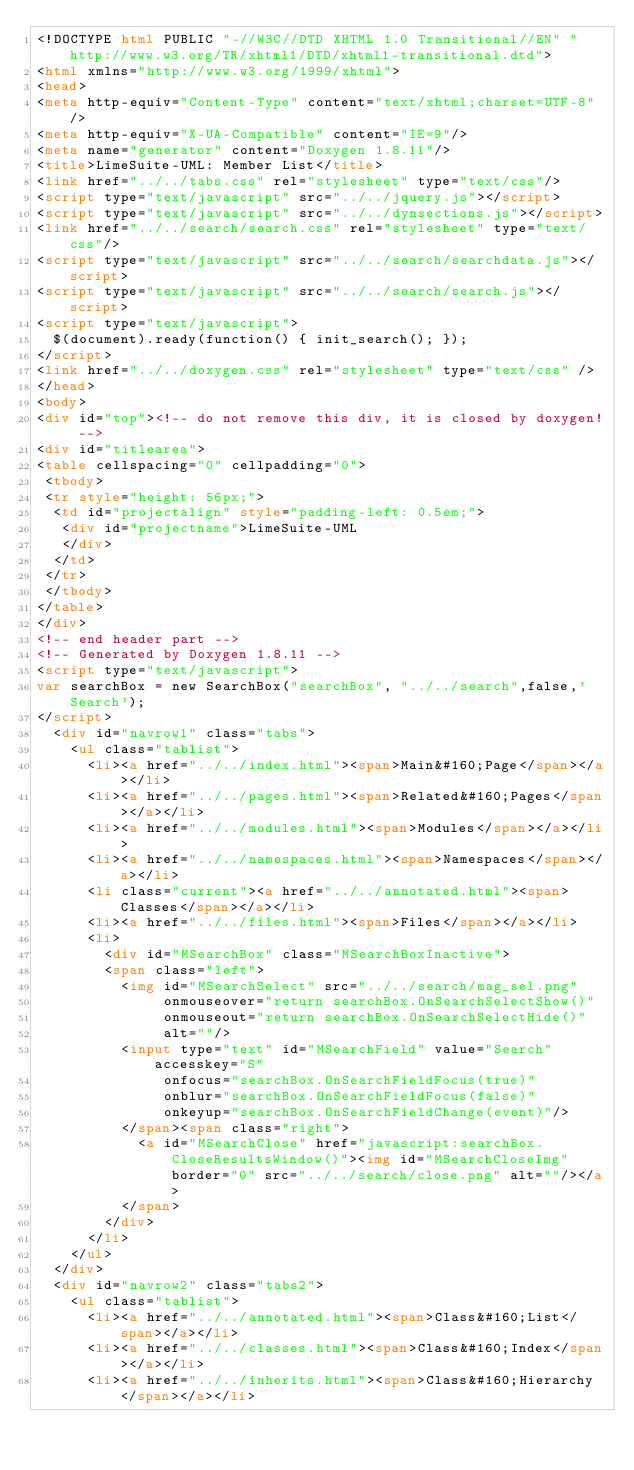Convert code to text. <code><loc_0><loc_0><loc_500><loc_500><_HTML_><!DOCTYPE html PUBLIC "-//W3C//DTD XHTML 1.0 Transitional//EN" "http://www.w3.org/TR/xhtml1/DTD/xhtml1-transitional.dtd">
<html xmlns="http://www.w3.org/1999/xhtml">
<head>
<meta http-equiv="Content-Type" content="text/xhtml;charset=UTF-8"/>
<meta http-equiv="X-UA-Compatible" content="IE=9"/>
<meta name="generator" content="Doxygen 1.8.11"/>
<title>LimeSuite-UML: Member List</title>
<link href="../../tabs.css" rel="stylesheet" type="text/css"/>
<script type="text/javascript" src="../../jquery.js"></script>
<script type="text/javascript" src="../../dynsections.js"></script>
<link href="../../search/search.css" rel="stylesheet" type="text/css"/>
<script type="text/javascript" src="../../search/searchdata.js"></script>
<script type="text/javascript" src="../../search/search.js"></script>
<script type="text/javascript">
  $(document).ready(function() { init_search(); });
</script>
<link href="../../doxygen.css" rel="stylesheet" type="text/css" />
</head>
<body>
<div id="top"><!-- do not remove this div, it is closed by doxygen! -->
<div id="titlearea">
<table cellspacing="0" cellpadding="0">
 <tbody>
 <tr style="height: 56px;">
  <td id="projectalign" style="padding-left: 0.5em;">
   <div id="projectname">LimeSuite-UML
   </div>
  </td>
 </tr>
 </tbody>
</table>
</div>
<!-- end header part -->
<!-- Generated by Doxygen 1.8.11 -->
<script type="text/javascript">
var searchBox = new SearchBox("searchBox", "../../search",false,'Search');
</script>
  <div id="navrow1" class="tabs">
    <ul class="tablist">
      <li><a href="../../index.html"><span>Main&#160;Page</span></a></li>
      <li><a href="../../pages.html"><span>Related&#160;Pages</span></a></li>
      <li><a href="../../modules.html"><span>Modules</span></a></li>
      <li><a href="../../namespaces.html"><span>Namespaces</span></a></li>
      <li class="current"><a href="../../annotated.html"><span>Classes</span></a></li>
      <li><a href="../../files.html"><span>Files</span></a></li>
      <li>
        <div id="MSearchBox" class="MSearchBoxInactive">
        <span class="left">
          <img id="MSearchSelect" src="../../search/mag_sel.png"
               onmouseover="return searchBox.OnSearchSelectShow()"
               onmouseout="return searchBox.OnSearchSelectHide()"
               alt=""/>
          <input type="text" id="MSearchField" value="Search" accesskey="S"
               onfocus="searchBox.OnSearchFieldFocus(true)" 
               onblur="searchBox.OnSearchFieldFocus(false)" 
               onkeyup="searchBox.OnSearchFieldChange(event)"/>
          </span><span class="right">
            <a id="MSearchClose" href="javascript:searchBox.CloseResultsWindow()"><img id="MSearchCloseImg" border="0" src="../../search/close.png" alt=""/></a>
          </span>
        </div>
      </li>
    </ul>
  </div>
  <div id="navrow2" class="tabs2">
    <ul class="tablist">
      <li><a href="../../annotated.html"><span>Class&#160;List</span></a></li>
      <li><a href="../../classes.html"><span>Class&#160;Index</span></a></li>
      <li><a href="../../inherits.html"><span>Class&#160;Hierarchy</span></a></li></code> 